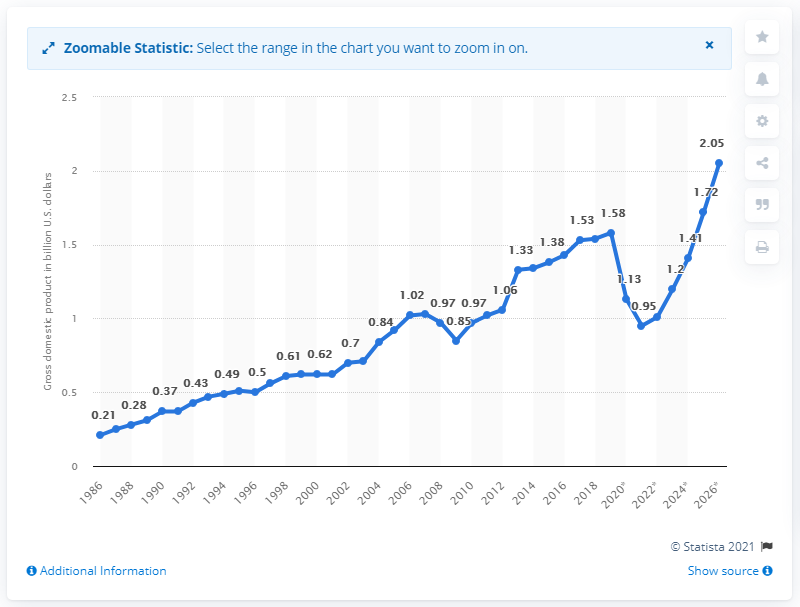Specify some key components in this picture. The gross domestic product of Seychelles in 2019 was 1.58. 